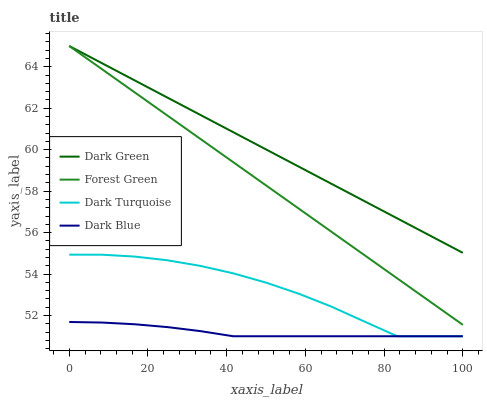Does Dark Blue have the minimum area under the curve?
Answer yes or no. Yes. Does Dark Green have the maximum area under the curve?
Answer yes or no. Yes. Does Forest Green have the minimum area under the curve?
Answer yes or no. No. Does Forest Green have the maximum area under the curve?
Answer yes or no. No. Is Dark Green the smoothest?
Answer yes or no. Yes. Is Dark Turquoise the roughest?
Answer yes or no. Yes. Is Forest Green the smoothest?
Answer yes or no. No. Is Forest Green the roughest?
Answer yes or no. No. Does Dark Turquoise have the lowest value?
Answer yes or no. Yes. Does Forest Green have the lowest value?
Answer yes or no. No. Does Dark Green have the highest value?
Answer yes or no. Yes. Does Dark Blue have the highest value?
Answer yes or no. No. Is Dark Turquoise less than Forest Green?
Answer yes or no. Yes. Is Dark Green greater than Dark Turquoise?
Answer yes or no. Yes. Does Dark Green intersect Forest Green?
Answer yes or no. Yes. Is Dark Green less than Forest Green?
Answer yes or no. No. Is Dark Green greater than Forest Green?
Answer yes or no. No. Does Dark Turquoise intersect Forest Green?
Answer yes or no. No. 